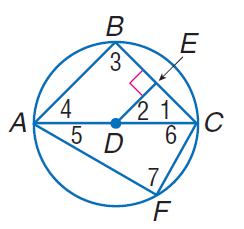Answer the mathemtical geometry problem and directly provide the correct option letter.
Question: In \odot D, D E \cong E C, m \widehat C F = 60, and D E \perp E C. Find m \widehat A F.
Choices: A: 30 B: 60 C: 90 D: 120 D 